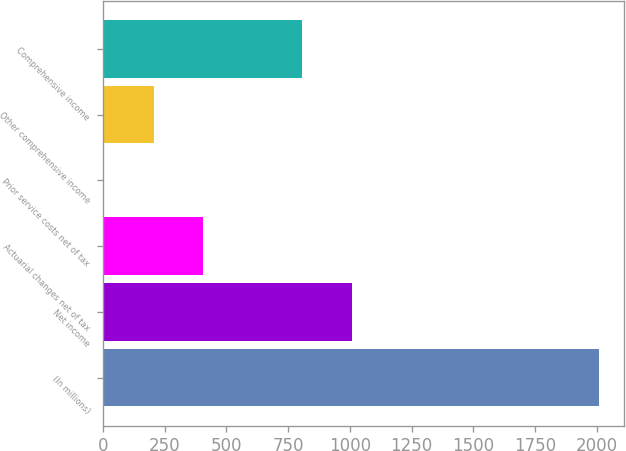<chart> <loc_0><loc_0><loc_500><loc_500><bar_chart><fcel>(In millions)<fcel>Net income<fcel>Actuarial changes net of tax<fcel>Prior service costs net of tax<fcel>Other comprehensive income<fcel>Comprehensive income<nl><fcel>2010<fcel>1007.5<fcel>406<fcel>5<fcel>205.5<fcel>807<nl></chart> 